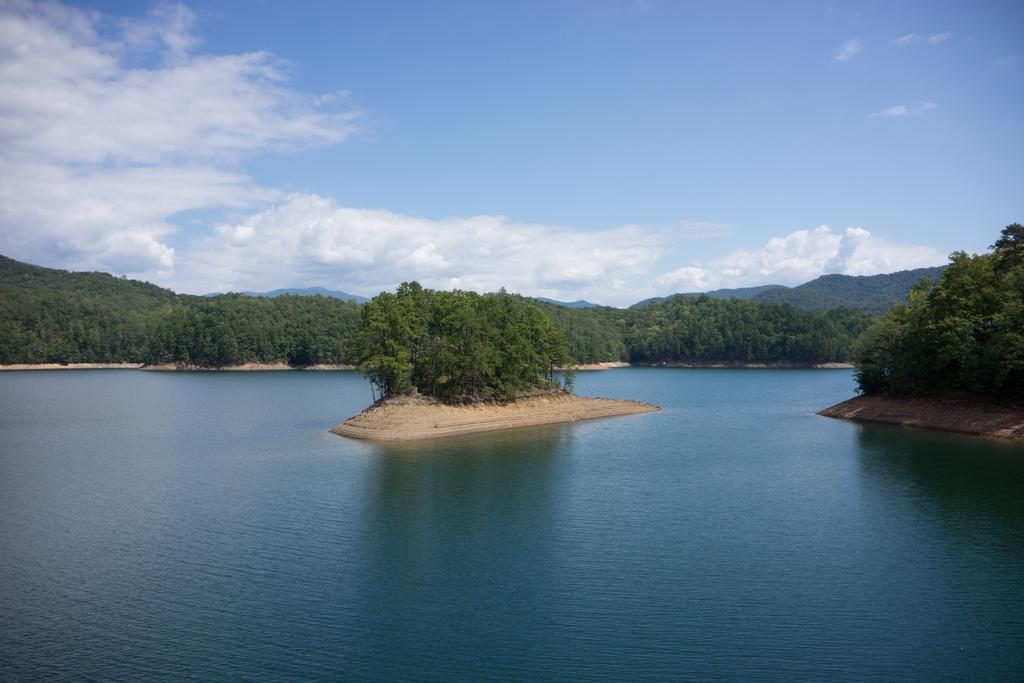What is the main subject of the image? The main subject of the image is an island. What can be found on the island? The island has trees. What surrounds the island? There is water surrounding the island. What can be seen in the background of the image? There are trees in the background of the image. What is visible in the sky in the image? The sky is visible in the image, and clouds are present. How many cats are sitting on the calculator in the image? There are no cats or calculators present in the image. 